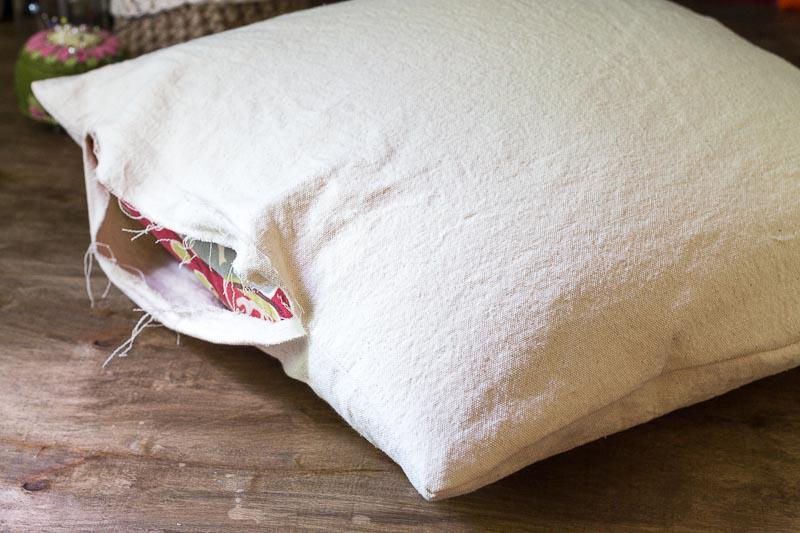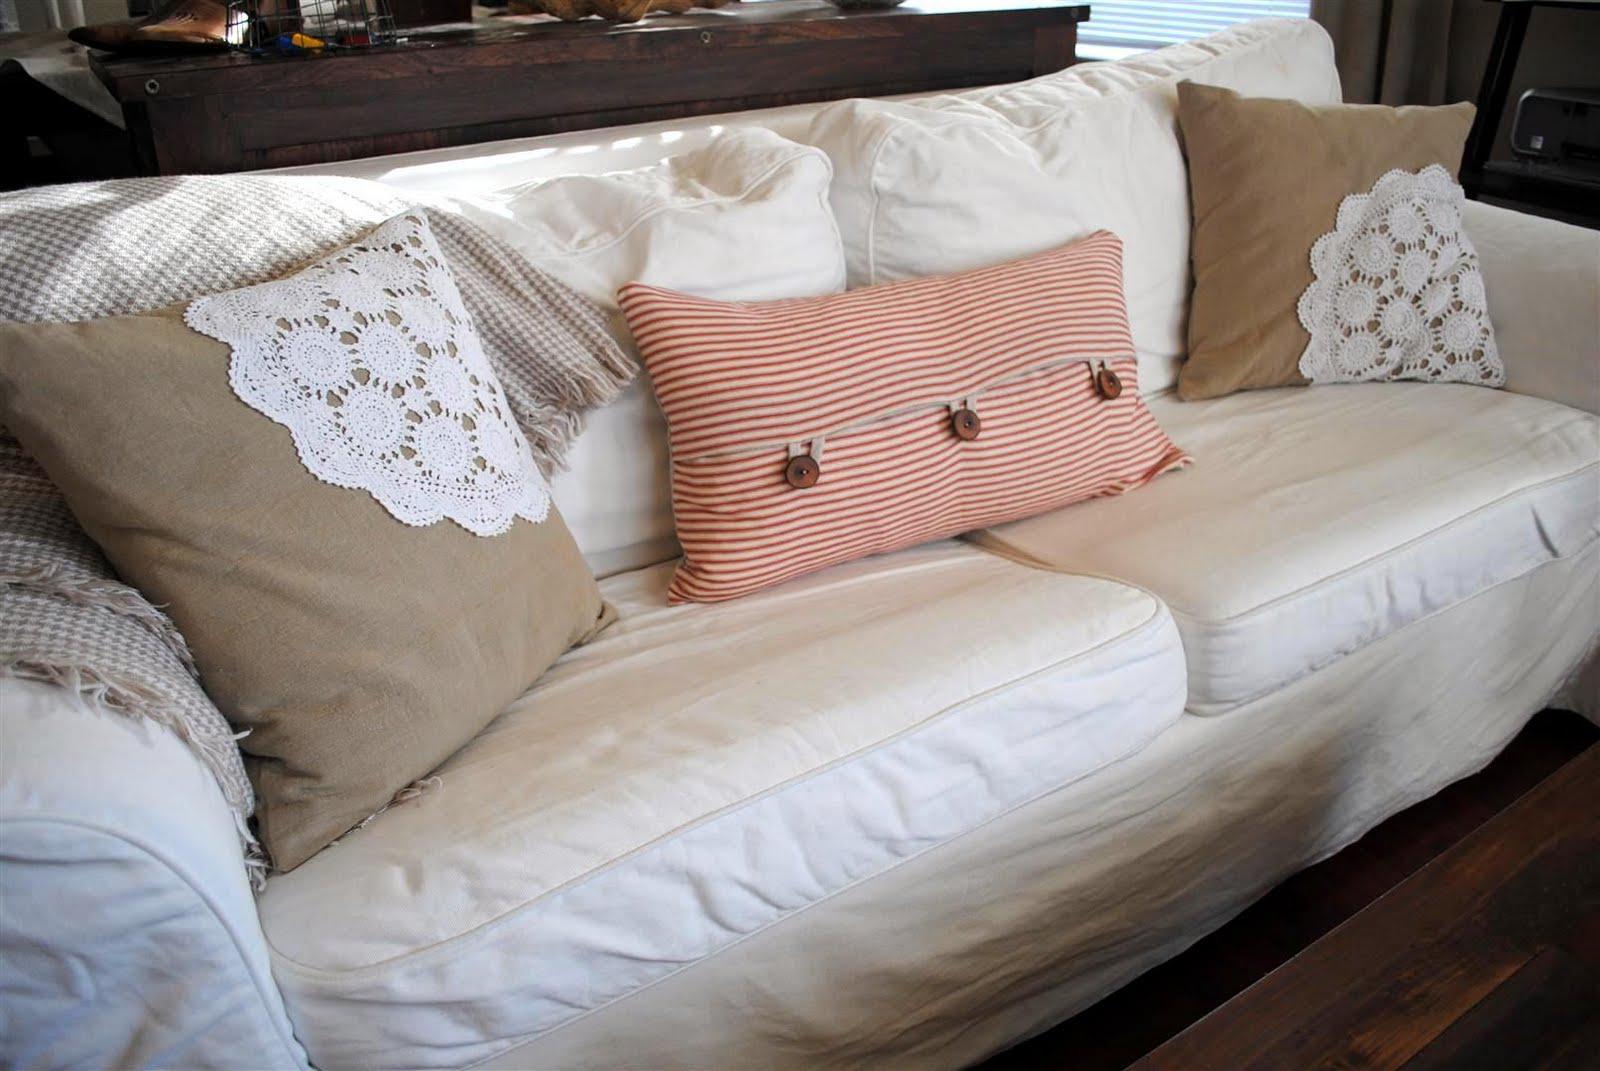The first image is the image on the left, the second image is the image on the right. Analyze the images presented: Is the assertion "There are at least three pillows in one of the images." valid? Answer yes or no. Yes. The first image is the image on the left, the second image is the image on the right. For the images displayed, is the sentence "An image features a square pillow with multiple rows of ruffles across its front." factually correct? Answer yes or no. No. 